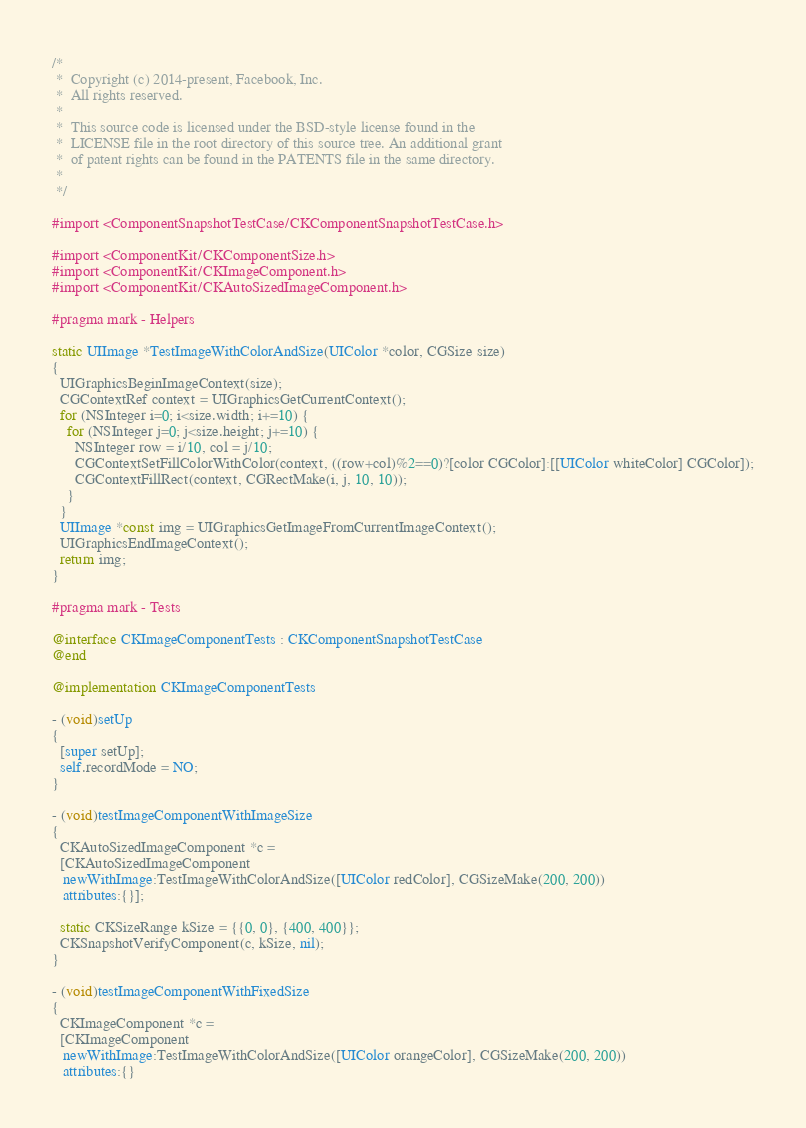Convert code to text. <code><loc_0><loc_0><loc_500><loc_500><_ObjectiveC_>/*
 *  Copyright (c) 2014-present, Facebook, Inc.
 *  All rights reserved.
 *
 *  This source code is licensed under the BSD-style license found in the
 *  LICENSE file in the root directory of this source tree. An additional grant
 *  of patent rights can be found in the PATENTS file in the same directory.
 *
 */

#import <ComponentSnapshotTestCase/CKComponentSnapshotTestCase.h>

#import <ComponentKit/CKComponentSize.h>
#import <ComponentKit/CKImageComponent.h>
#import <ComponentKit/CKAutoSizedImageComponent.h>

#pragma mark - Helpers

static UIImage *TestImageWithColorAndSize(UIColor *color, CGSize size)
{
  UIGraphicsBeginImageContext(size);
  CGContextRef context = UIGraphicsGetCurrentContext();
  for (NSInteger i=0; i<size.width; i+=10) {
    for (NSInteger j=0; j<size.height; j+=10) {
      NSInteger row = i/10, col = j/10;
      CGContextSetFillColorWithColor(context, ((row+col)%2==0)?[color CGColor]:[[UIColor whiteColor] CGColor]);
      CGContextFillRect(context, CGRectMake(i, j, 10, 10));
    }
  }
  UIImage *const img = UIGraphicsGetImageFromCurrentImageContext();
  UIGraphicsEndImageContext();
  return img;
}

#pragma mark - Tests

@interface CKImageComponentTests : CKComponentSnapshotTestCase
@end

@implementation CKImageComponentTests

- (void)setUp
{
  [super setUp];
  self.recordMode = NO;
}

- (void)testImageComponentWithImageSize
{
  CKAutoSizedImageComponent *c =
  [CKAutoSizedImageComponent
   newWithImage:TestImageWithColorAndSize([UIColor redColor], CGSizeMake(200, 200))
   attributes:{}];

  static CKSizeRange kSize = {{0, 0}, {400, 400}};
  CKSnapshotVerifyComponent(c, kSize, nil);
}

- (void)testImageComponentWithFixedSize
{
  CKImageComponent *c =
  [CKImageComponent
   newWithImage:TestImageWithColorAndSize([UIColor orangeColor], CGSizeMake(200, 200))
   attributes:{}</code> 